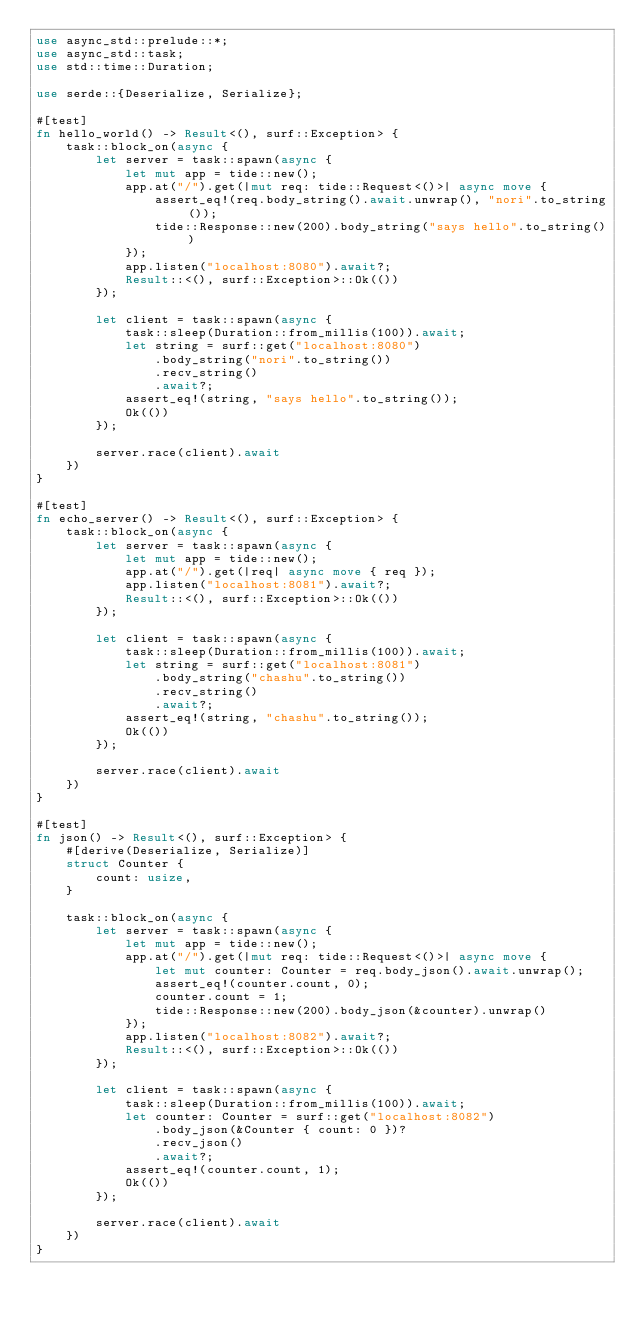Convert code to text. <code><loc_0><loc_0><loc_500><loc_500><_Rust_>use async_std::prelude::*;
use async_std::task;
use std::time::Duration;

use serde::{Deserialize, Serialize};

#[test]
fn hello_world() -> Result<(), surf::Exception> {
    task::block_on(async {
        let server = task::spawn(async {
            let mut app = tide::new();
            app.at("/").get(|mut req: tide::Request<()>| async move {
                assert_eq!(req.body_string().await.unwrap(), "nori".to_string());
                tide::Response::new(200).body_string("says hello".to_string())
            });
            app.listen("localhost:8080").await?;
            Result::<(), surf::Exception>::Ok(())
        });

        let client = task::spawn(async {
            task::sleep(Duration::from_millis(100)).await;
            let string = surf::get("localhost:8080")
                .body_string("nori".to_string())
                .recv_string()
                .await?;
            assert_eq!(string, "says hello".to_string());
            Ok(())
        });

        server.race(client).await
    })
}

#[test]
fn echo_server() -> Result<(), surf::Exception> {
    task::block_on(async {
        let server = task::spawn(async {
            let mut app = tide::new();
            app.at("/").get(|req| async move { req });
            app.listen("localhost:8081").await?;
            Result::<(), surf::Exception>::Ok(())
        });

        let client = task::spawn(async {
            task::sleep(Duration::from_millis(100)).await;
            let string = surf::get("localhost:8081")
                .body_string("chashu".to_string())
                .recv_string()
                .await?;
            assert_eq!(string, "chashu".to_string());
            Ok(())
        });

        server.race(client).await
    })
}

#[test]
fn json() -> Result<(), surf::Exception> {
    #[derive(Deserialize, Serialize)]
    struct Counter {
        count: usize,
    }

    task::block_on(async {
        let server = task::spawn(async {
            let mut app = tide::new();
            app.at("/").get(|mut req: tide::Request<()>| async move {
                let mut counter: Counter = req.body_json().await.unwrap();
                assert_eq!(counter.count, 0);
                counter.count = 1;
                tide::Response::new(200).body_json(&counter).unwrap()
            });
            app.listen("localhost:8082").await?;
            Result::<(), surf::Exception>::Ok(())
        });

        let client = task::spawn(async {
            task::sleep(Duration::from_millis(100)).await;
            let counter: Counter = surf::get("localhost:8082")
                .body_json(&Counter { count: 0 })?
                .recv_json()
                .await?;
            assert_eq!(counter.count, 1);
            Ok(())
        });

        server.race(client).await
    })
}
</code> 